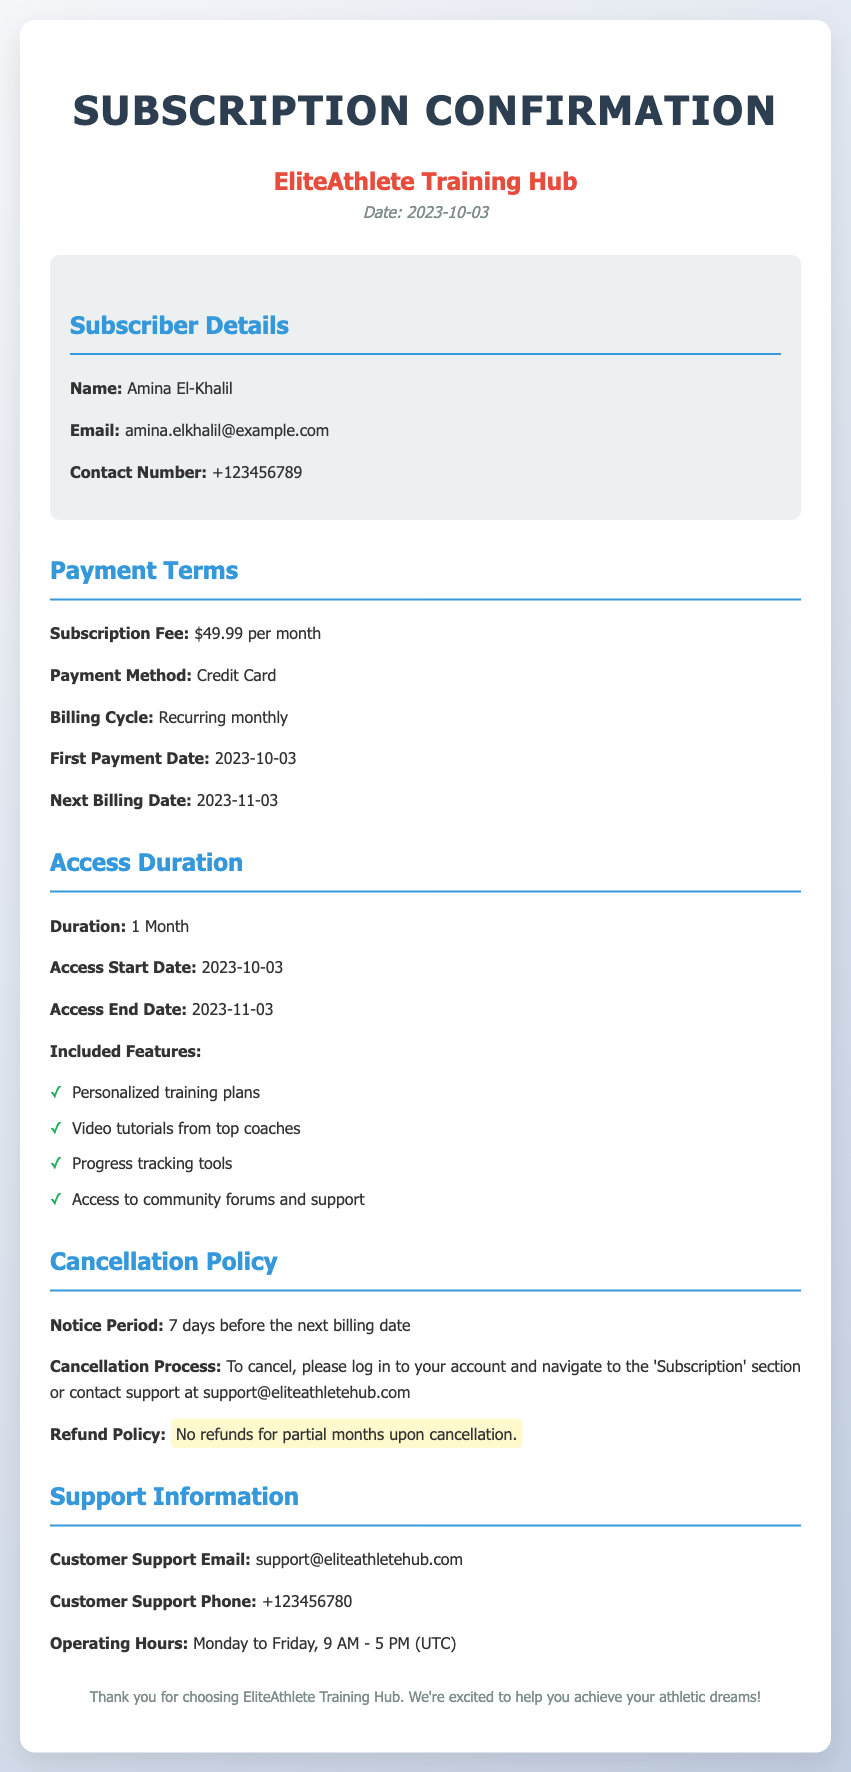What is the subscription fee? The subscription fee is stated in the document as $49.99 per month.
Answer: $49.99 per month What is the access end date? The document indicates that the access end date is when the subscription duration concludes, which is 2023-11-03.
Answer: 2023-11-03 What is the notice period for cancellation? The notice period, according to the document, is specified before the next billing date, which is 7 days.
Answer: 7 days What is included in the features? The document lists several features included in the subscription, such as personalized training plans and others.
Answer: Personalized training plans, Video tutorials from top coaches, Progress tracking tools, Access to community forums and support How can I cancel my subscription? The cancellation process is explained in the document, stating to log in and navigate to the 'Subscription' section or to contact support.
Answer: Log in or contact support What is the first payment date? The first payment date mentioned in the document is the date the subscription begins, which is 2023-10-03.
Answer: 2023-10-03 What are the operating hours for customer support? The operating hours for customer support are specified in the document as Monday to Friday from 9 AM to 5 PM (UTC).
Answer: Monday to Friday, 9 AM - 5 PM (UTC) What method of payment is accepted? The document states that the payment method accepted for the subscription is Credit Card.
Answer: Credit Card 